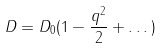<formula> <loc_0><loc_0><loc_500><loc_500>D = D _ { 0 } ( 1 - \frac { q ^ { 2 } } { 2 } + \dots )</formula> 